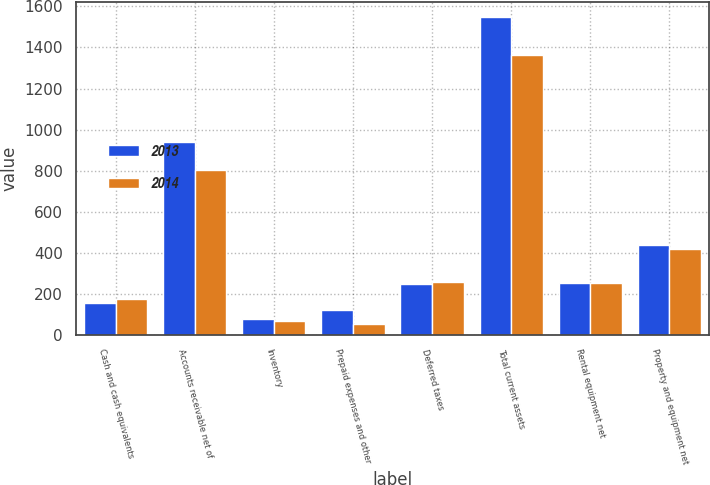Convert chart. <chart><loc_0><loc_0><loc_500><loc_500><stacked_bar_chart><ecel><fcel>Cash and cash equivalents<fcel>Accounts receivable net of<fcel>Inventory<fcel>Prepaid expenses and other<fcel>Deferred taxes<fcel>Total current assets<fcel>Rental equipment net<fcel>Property and equipment net<nl><fcel>2013<fcel>158<fcel>940<fcel>78<fcel>122<fcel>248<fcel>1546<fcel>254<fcel>438<nl><fcel>2014<fcel>175<fcel>804<fcel>70<fcel>53<fcel>260<fcel>1362<fcel>254<fcel>421<nl></chart> 